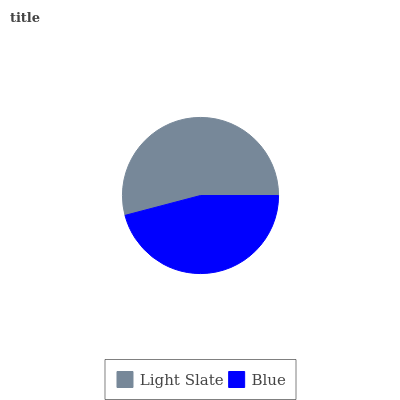Is Blue the minimum?
Answer yes or no. Yes. Is Light Slate the maximum?
Answer yes or no. Yes. Is Blue the maximum?
Answer yes or no. No. Is Light Slate greater than Blue?
Answer yes or no. Yes. Is Blue less than Light Slate?
Answer yes or no. Yes. Is Blue greater than Light Slate?
Answer yes or no. No. Is Light Slate less than Blue?
Answer yes or no. No. Is Light Slate the high median?
Answer yes or no. Yes. Is Blue the low median?
Answer yes or no. Yes. Is Blue the high median?
Answer yes or no. No. Is Light Slate the low median?
Answer yes or no. No. 